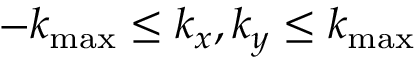<formula> <loc_0><loc_0><loc_500><loc_500>- k _ { \max } \leq k _ { x } , k _ { y } \leq k _ { \max }</formula> 